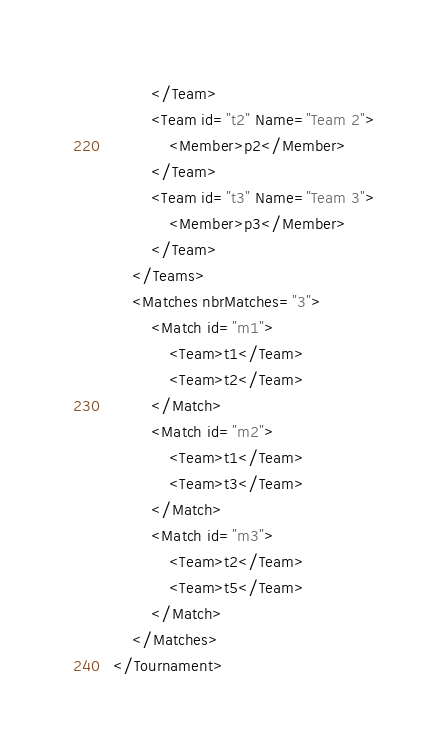Convert code to text. <code><loc_0><loc_0><loc_500><loc_500><_XML_>		</Team>
		<Team id="t2" Name="Team 2">
			<Member>p2</Member>
		</Team>
		<Team id="t3" Name="Team 3">
			<Member>p3</Member>
		</Team>
	</Teams>
	<Matches nbrMatches="3">
		<Match id="m1">
			<Team>t1</Team>
			<Team>t2</Team>
		</Match>
		<Match id="m2">
			<Team>t1</Team>
			<Team>t3</Team>
		</Match>
		<Match id="m3">
			<Team>t2</Team>
			<Team>t5</Team>
		</Match>
	</Matches>
</Tournament>
</code> 